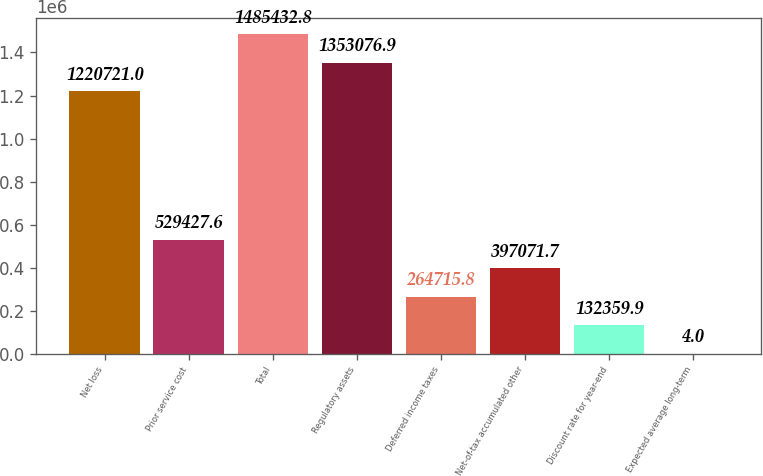<chart> <loc_0><loc_0><loc_500><loc_500><bar_chart><fcel>Net loss<fcel>Prior service cost<fcel>Total<fcel>Regulatory assets<fcel>Deferred income taxes<fcel>Net-of-tax accumulated other<fcel>Discount rate for year-end<fcel>Expected average long-term<nl><fcel>1.22072e+06<fcel>529428<fcel>1.48543e+06<fcel>1.35308e+06<fcel>264716<fcel>397072<fcel>132360<fcel>4<nl></chart> 